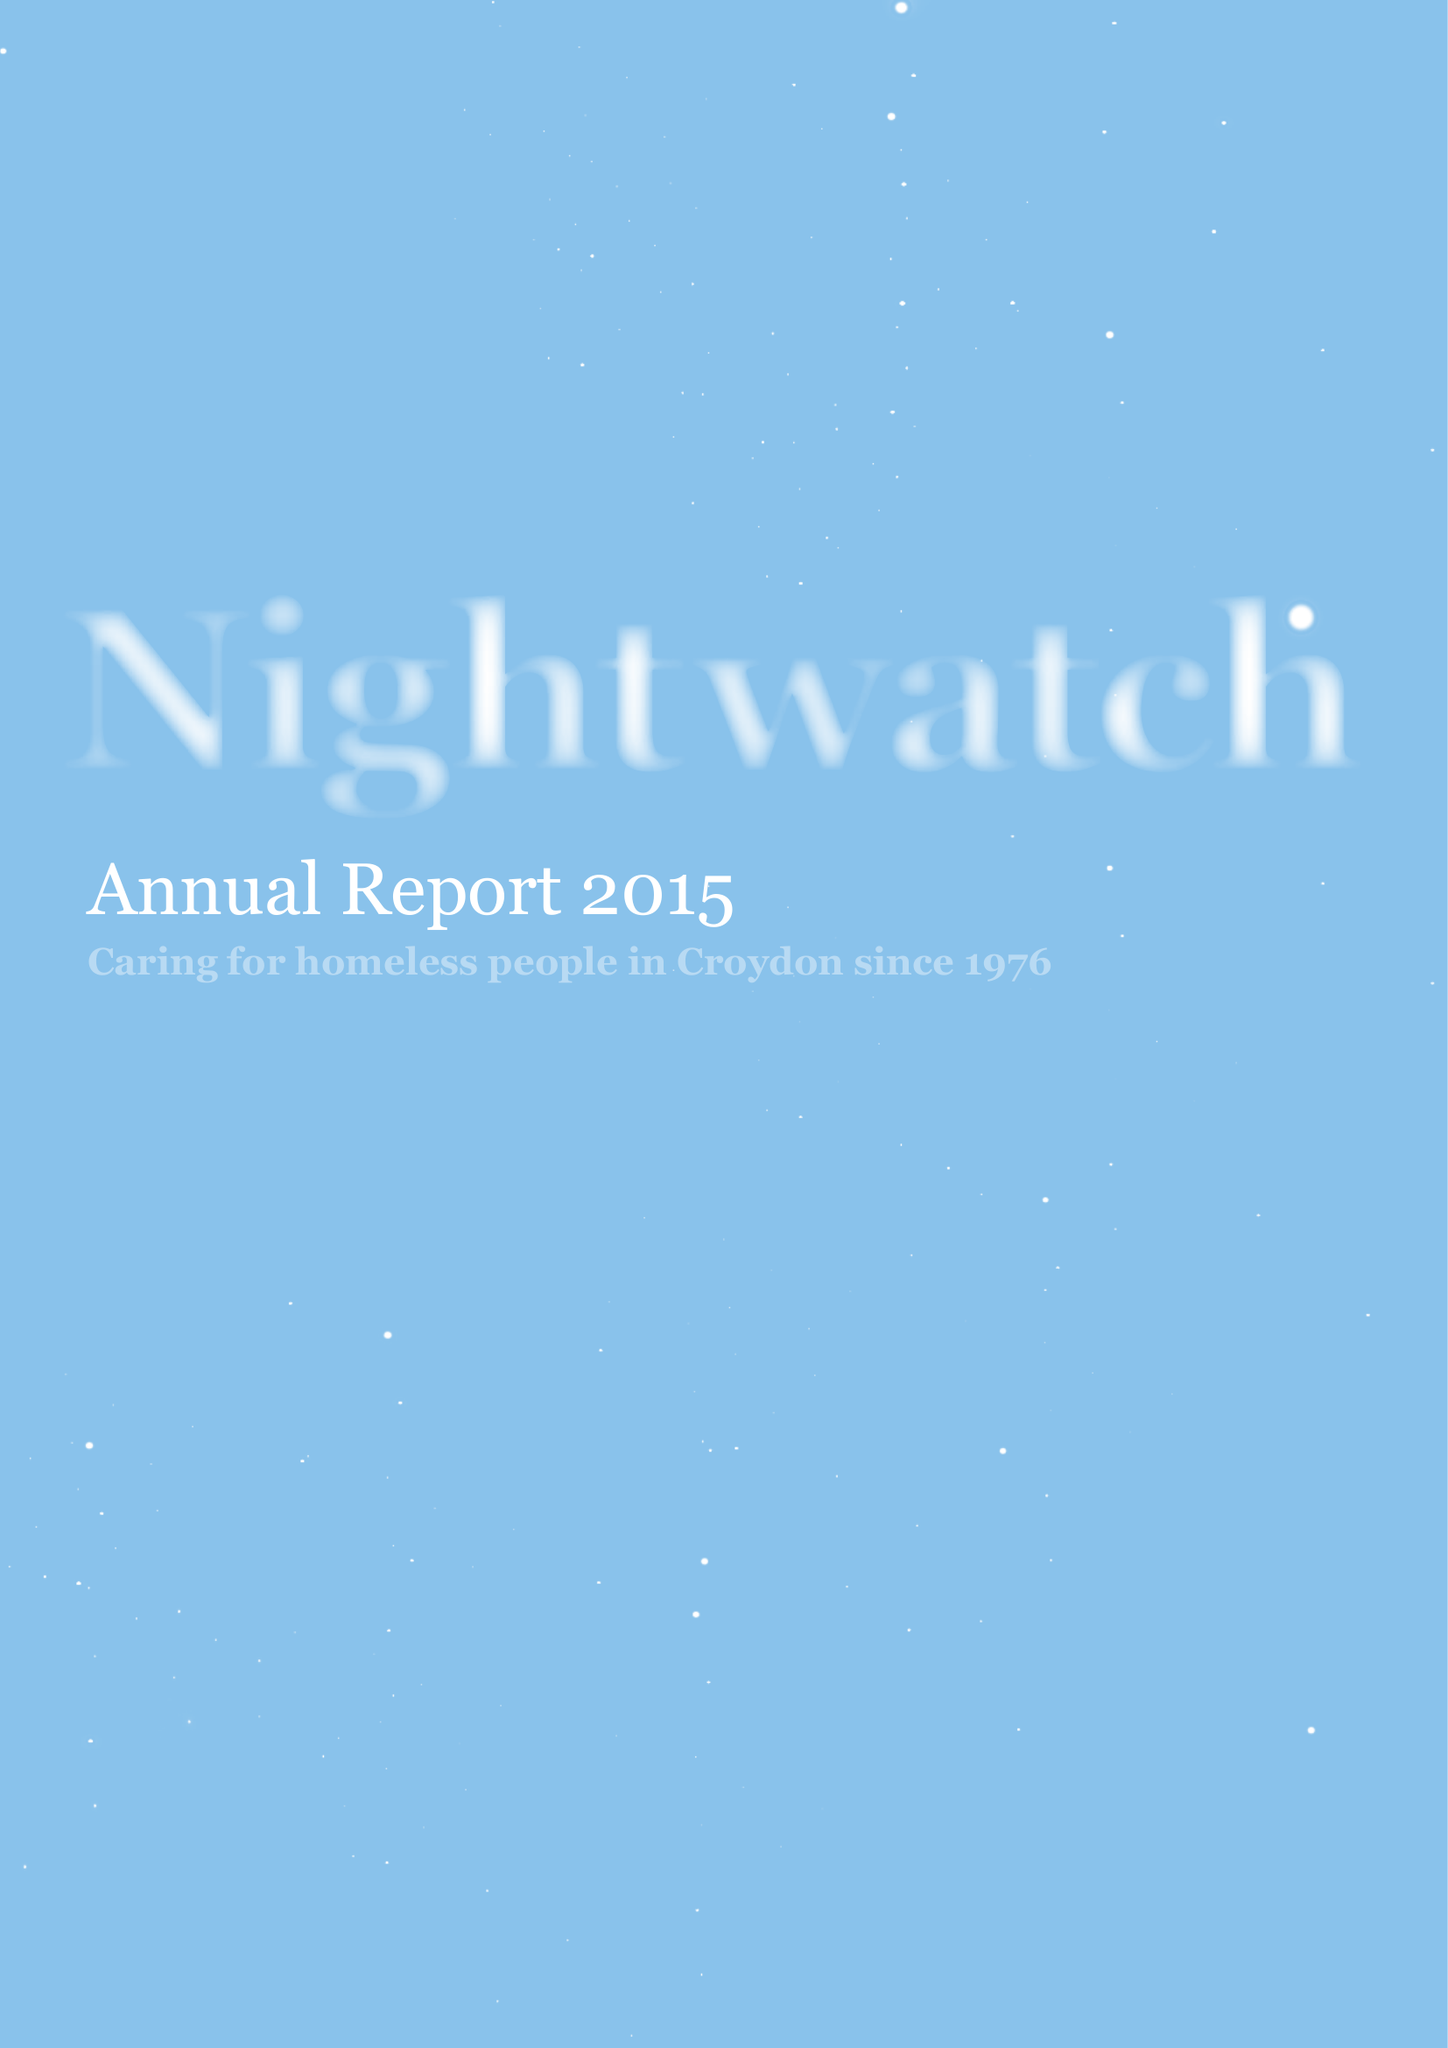What is the value for the address__street_line?
Answer the question using a single word or phrase. PO BOX 9576 